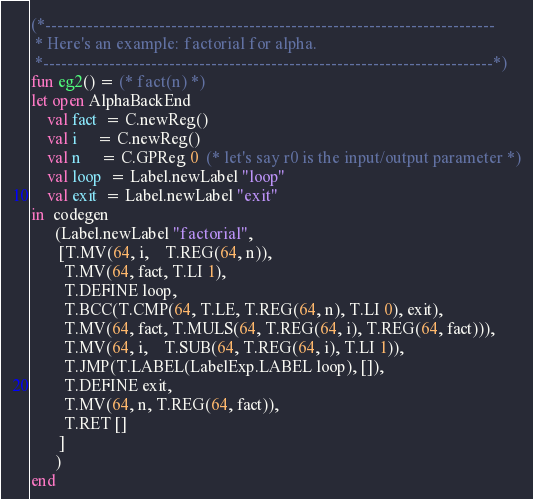<code> <loc_0><loc_0><loc_500><loc_500><_SML_>(*---------------------------------------------------------------------------
 * Here's an example: factorial for alpha.
 *---------------------------------------------------------------------------*)
fun eg2() = (* fact(n) *)
let open AlphaBackEnd
    val fact  = C.newReg()
    val i     = C.newReg()
    val n     = C.GPReg 0  (* let's say r0 is the input/output parameter *)
    val loop  = Label.newLabel "loop"
    val exit  = Label.newLabel "exit"
in  codegen
      (Label.newLabel "factorial",
       [T.MV(64, i,    T.REG(64, n)),
        T.MV(64, fact, T.LI 1),
        T.DEFINE loop,
        T.BCC(T.CMP(64, T.LE, T.REG(64, n), T.LI 0), exit),
        T.MV(64, fact, T.MULS(64, T.REG(64, i), T.REG(64, fact))),
        T.MV(64, i,    T.SUB(64, T.REG(64, i), T.LI 1)),
        T.JMP(T.LABEL(LabelExp.LABEL loop), []),
        T.DEFINE exit,
        T.MV(64, n, T.REG(64, fact)),
        T.RET []
       ]
      )
end
</code> 